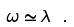<formula> <loc_0><loc_0><loc_500><loc_500>\omega \simeq \lambda \ .</formula> 